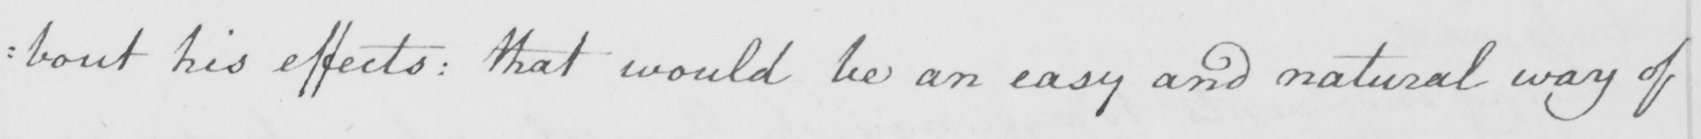Please provide the text content of this handwritten line. : bout his effects :  that would be an easy and natural way of 